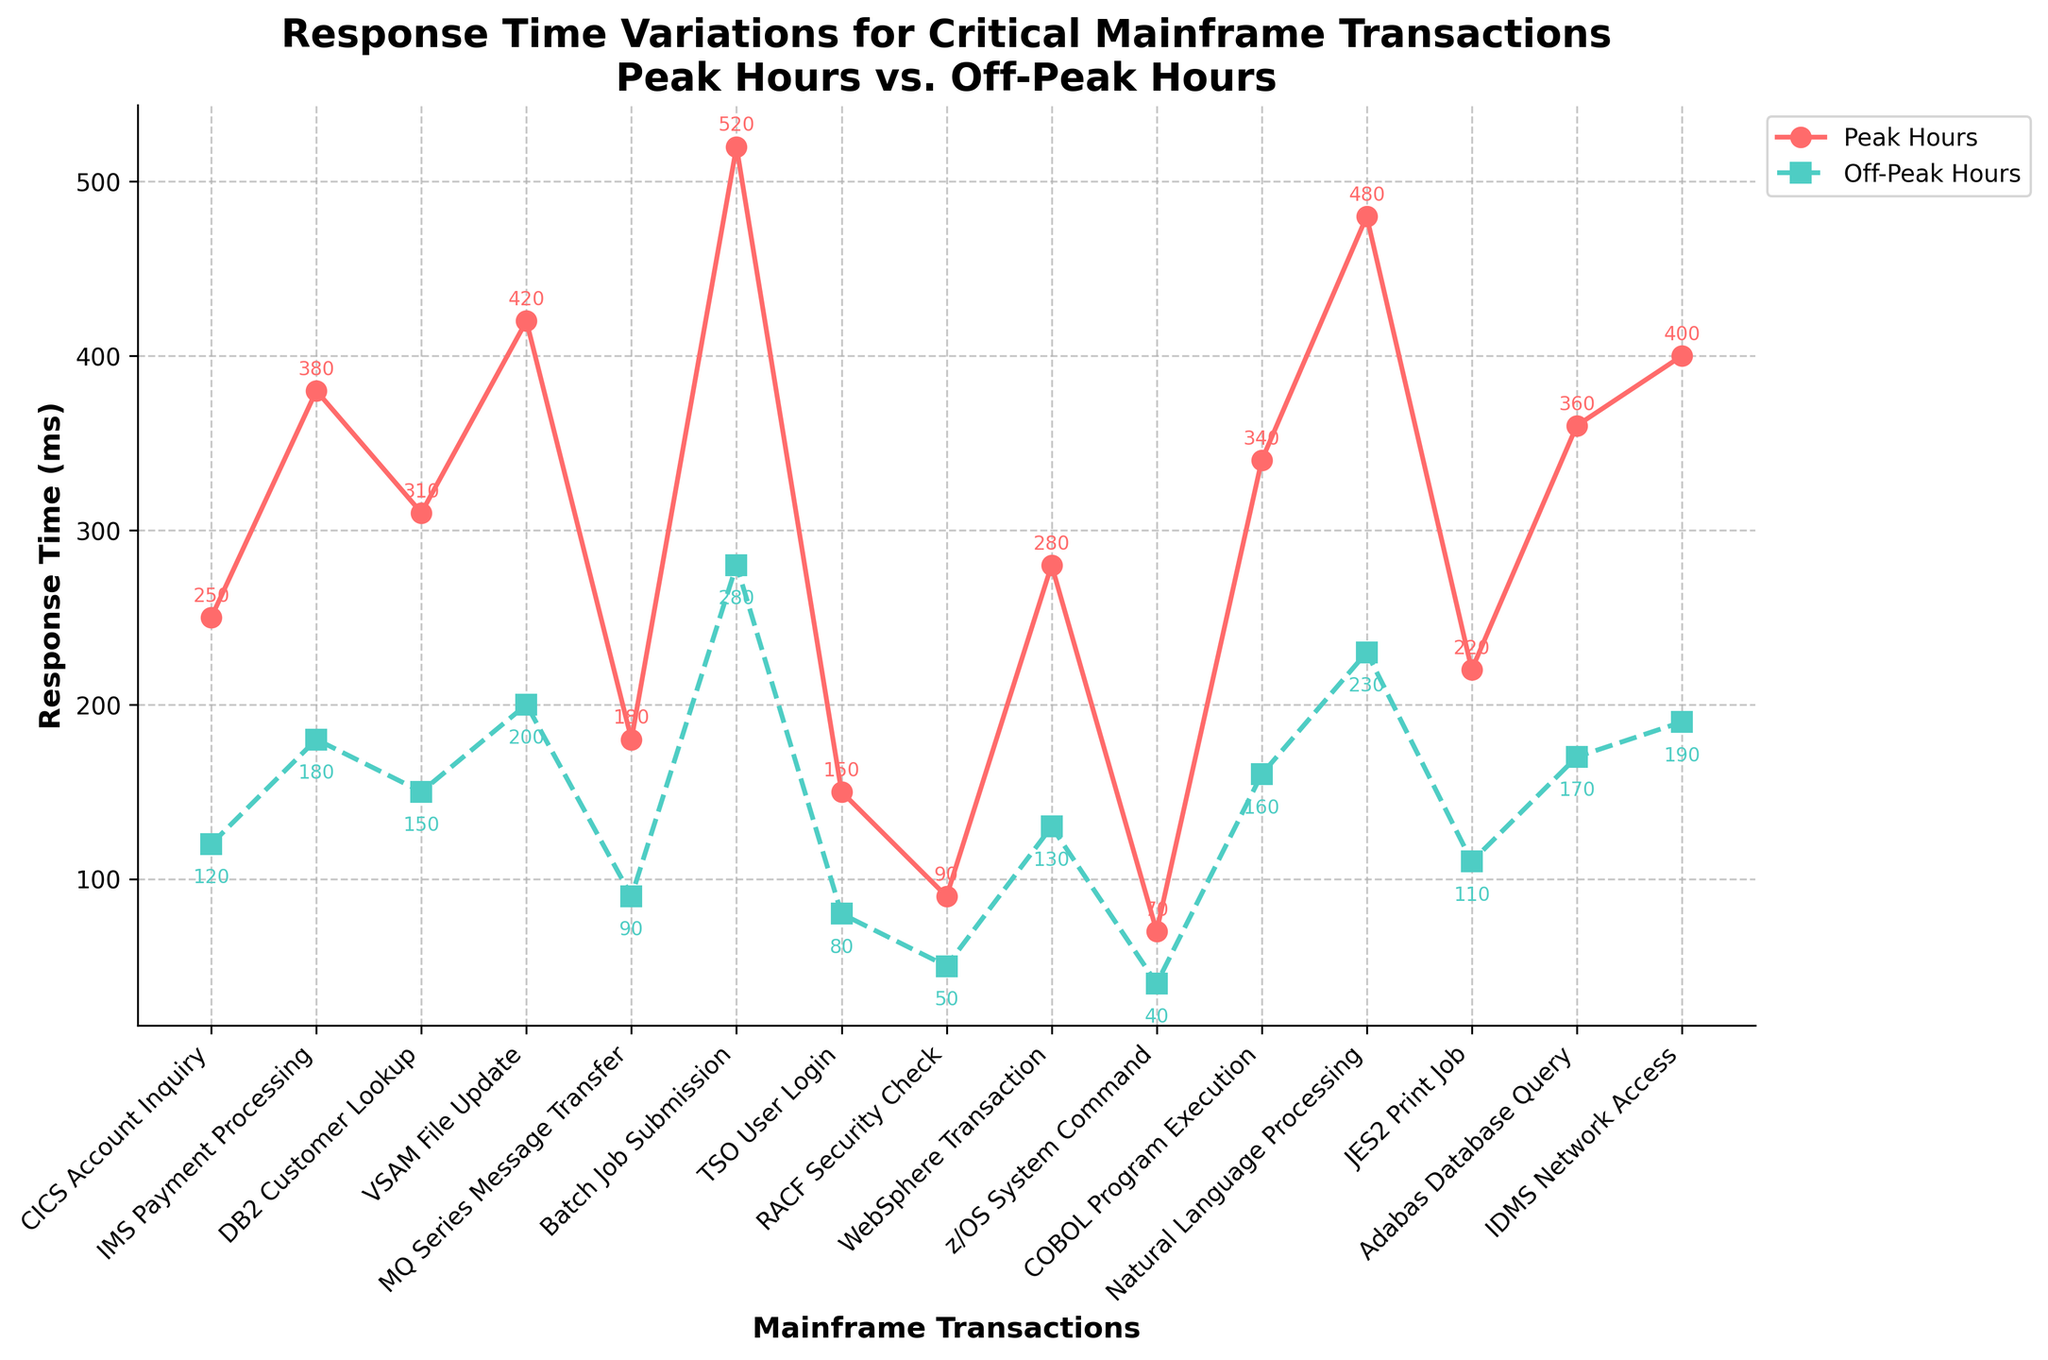Which mainframe transaction has the highest response time during peak hours? By looking at the graph, identify the data point with the highest vertical position on the "Peak Hours" line. This represents the transaction with the highest response time during peak hours.
Answer: Batch Job Submission Which transaction type shows the largest difference in response times between peak and off-peak hours? Calculate the difference in response times for each transaction type and find the one with the largest difference by comparing the lengths of the vertical gaps between each pair of lines.
Answer: Batch Job Submission How does the response time of IMS Payment Processing during peak hours compare to Natural Language Processing? Locate the IMS Payment Processing and Natural Language Processing points on the Peak Hours line and compare their vertical positions.
Answer: IMS Payment Processing is lower (380 ms vs. 480 ms) Which transaction has lower response times in both peak and off-peak hours: WebSphere Transaction or COBOL Program Execution? Compare the vertical positions for both transactions on both Peak Hours and Off-Peak Hours lines.
Answer: WebSphere Transaction What is the average response time of CICS Account Inquiry and DB2 Customer Lookup during peak hours? Find the response times for CICS Account Inquiry and DB2 Customer Lookup during peak hours, sum them, and divide by 2. (250 + 310) / 2 = 280
Answer: 280 ms Are there any transactions with the same off-peak response time? Check the Off-Peak Hours line for any overlapping or identical data points.
Answer: No, all are unique What visual element helps differentiate peak hour data from off-peak data? Identify visual differences such as color, line style, or marker type used in the plot.
Answer: Different colors and line styles Which transaction has the smallest difference in response times between peak and off-peak hours? Calculate the difference in response times for each transaction type and find the one with the smallest difference.
Answer: TSO User Login (70 ms) What is the sum of peak hours response times for JE2 Print Job and Adabas Database Query? Add the peak hours response times for JES2 Print Job and Adabas Database Query. (220 + 360) = 580
Answer: 580 ms Which has higher off-peak response time: z/OS System Command or RACF Security Check? Compare the vertical positions of z/OS System Command and RACF Security Check on the Off-Peak Hours line.
Answer: z/OS System Command 